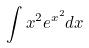Convert formula to latex. <formula><loc_0><loc_0><loc_500><loc_500>\int x ^ { 2 } e ^ { x ^ { 2 } } d x</formula> 